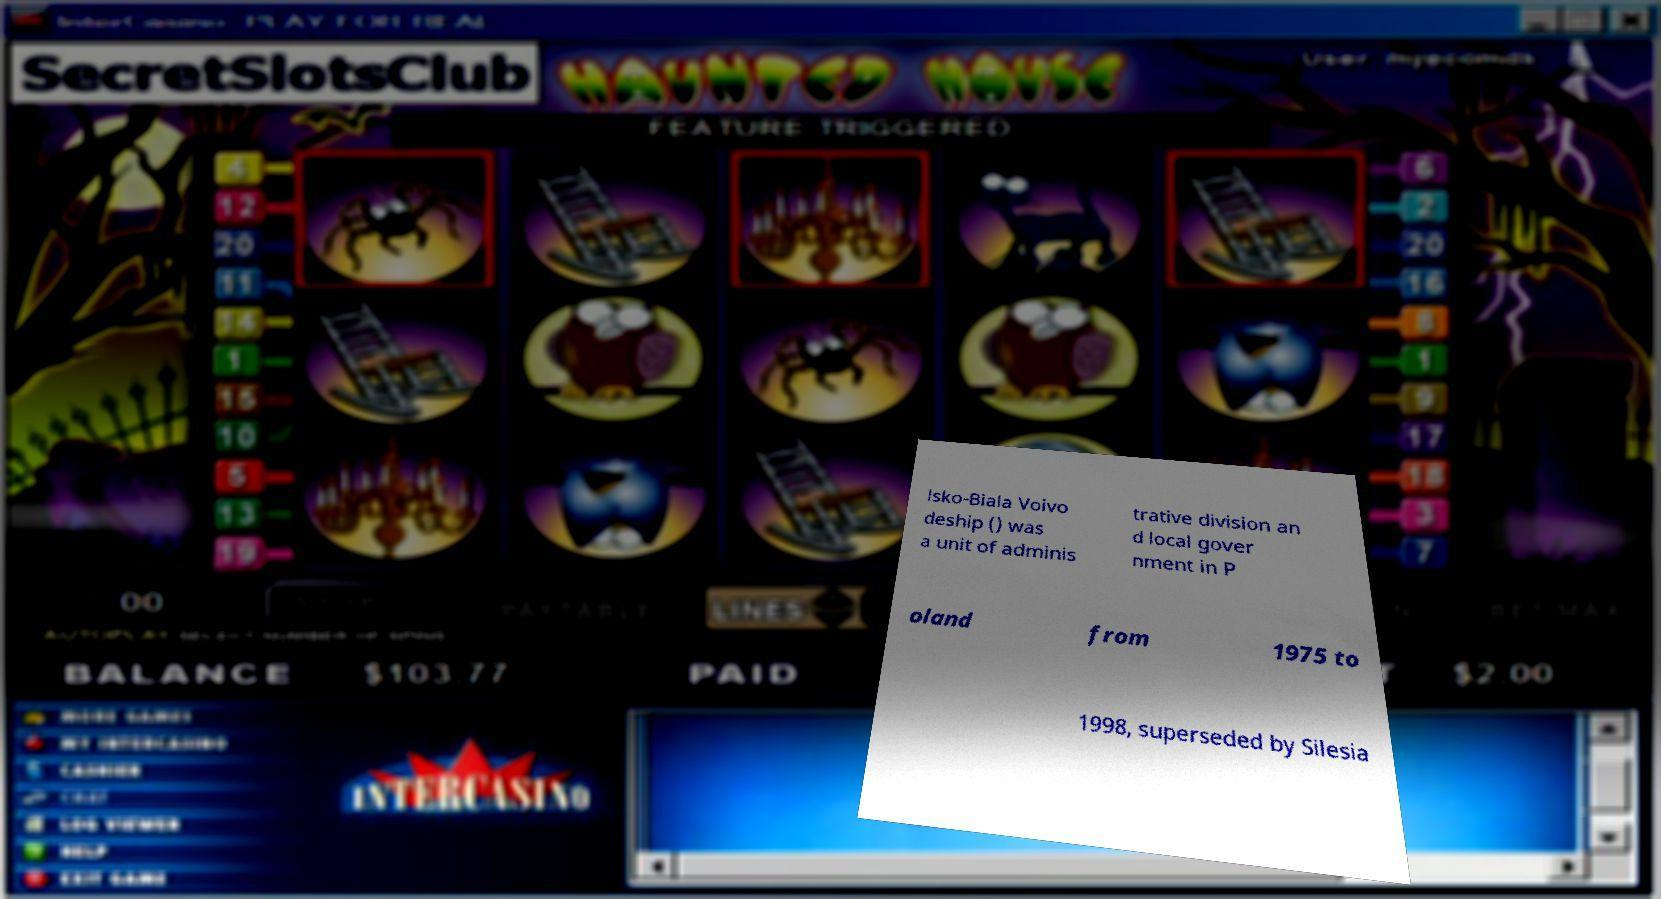Can you accurately transcribe the text from the provided image for me? lsko-Biala Voivo deship () was a unit of adminis trative division an d local gover nment in P oland from 1975 to 1998, superseded by Silesia 